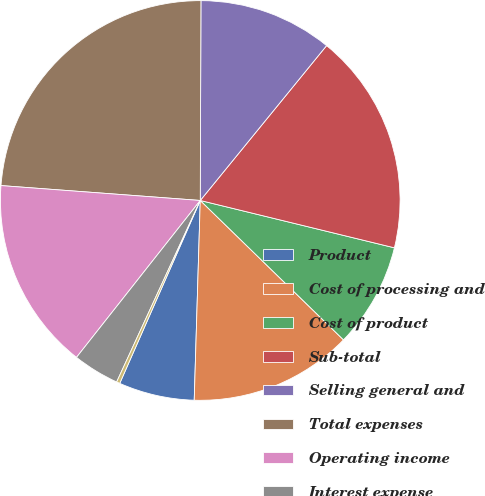<chart> <loc_0><loc_0><loc_500><loc_500><pie_chart><fcel>Product<fcel>Cost of processing and<fcel>Cost of product<fcel>Sub-total<fcel>Selling general and<fcel>Total expenses<fcel>Operating income<fcel>Interest expense<fcel>Interest and investment income<nl><fcel>6.12%<fcel>13.2%<fcel>8.48%<fcel>17.92%<fcel>10.84%<fcel>23.87%<fcel>15.56%<fcel>3.76%<fcel>0.27%<nl></chart> 